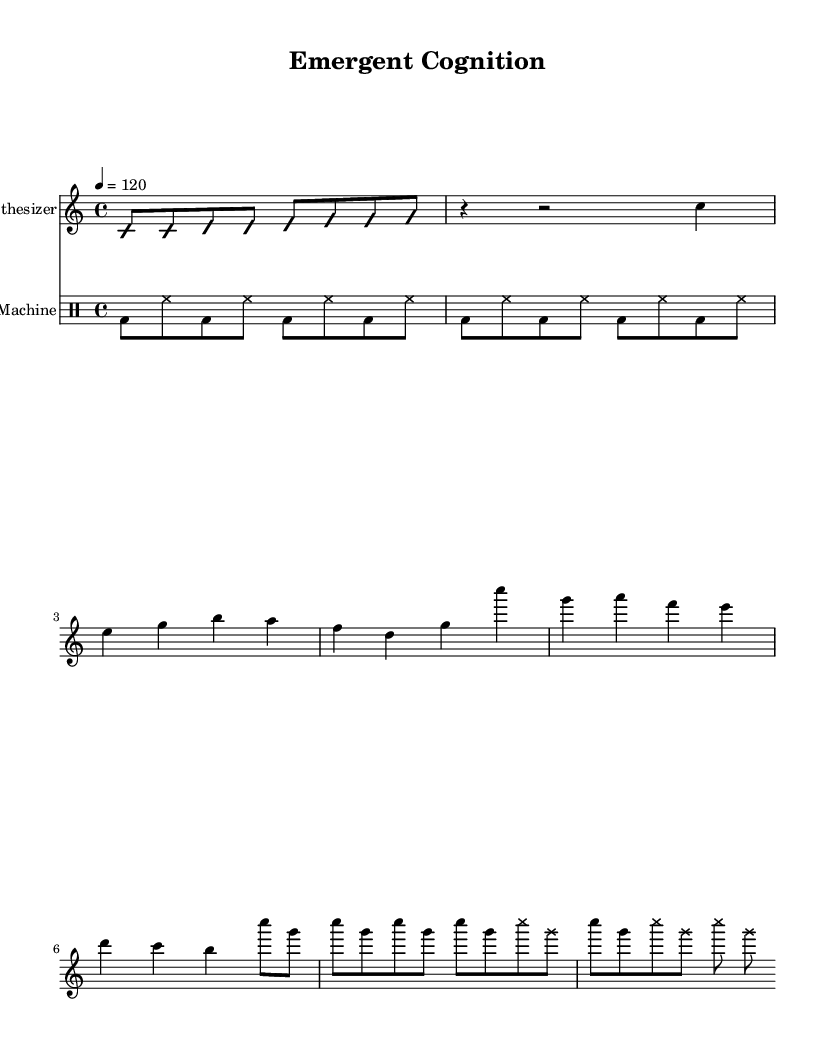What is the key signature of this music? The key signature is indicated at the beginning of the sheet music and shows that there are no accidentals (sharps or flats) in the piece, which signifies the C major scale.
Answer: C major What is the time signature of this music? The time signature is found at the beginning of the score. In this case, it is 4/4, meaning there are four beats in each measure and the quarter note gets one beat.
Answer: 4/4 What is the tempo marking for this music? The tempo marking, indicated by the number 120 at the beginning, signifies the speed of the piece, suggesting that it should be played at 120 beats per minute.
Answer: 120 How many measures are in the "Chorus" section? By reviewing the notation under the "Chorus" label, you can count the number of measures in that section which totals four distinct measure notations.
Answer: 4 What rhythmic pattern do the drums follow? Analyzing the drum part, the pattern repeats, consisting of a kick drum followed by a hi-hat and then another kick drum within a four-beat framework as denoted in the drummode section.
Answer: Kick-hat pattern What indicates the use of improvisation in the "Intro"? The "Intro" section is marked with the indicators "improvisationOn" and "improvisationOff", signaling that it allows for free expression within that part of the music.
Answer: Improvisation indicators What type of music is represented in this sheet music? The music is characterized by electronic elements, such as synthesized sounds and structured rhythm, particularly noted from the use of synthesizer and drum machine.
Answer: Electronic 